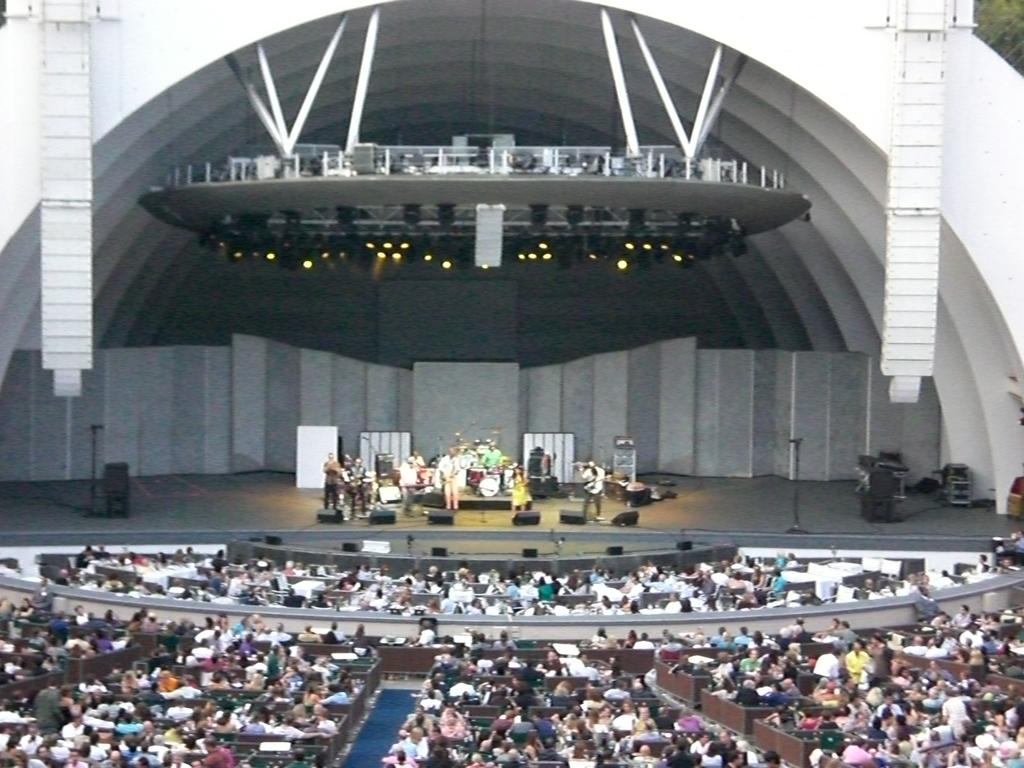What is happening in the center of the image? There are people standing on the stage in the center of the image. What is used to amplify sound in the image? There are speakers present in the image. What can be seen at the bottom of the image? There is a crowd at the bottom of the image. What is visible at the top of the image? There are lights visible at the top of the image. Is there a board visible in the image? There is no board present in the image. Can you see an island in the image? There is no island present in the image. 